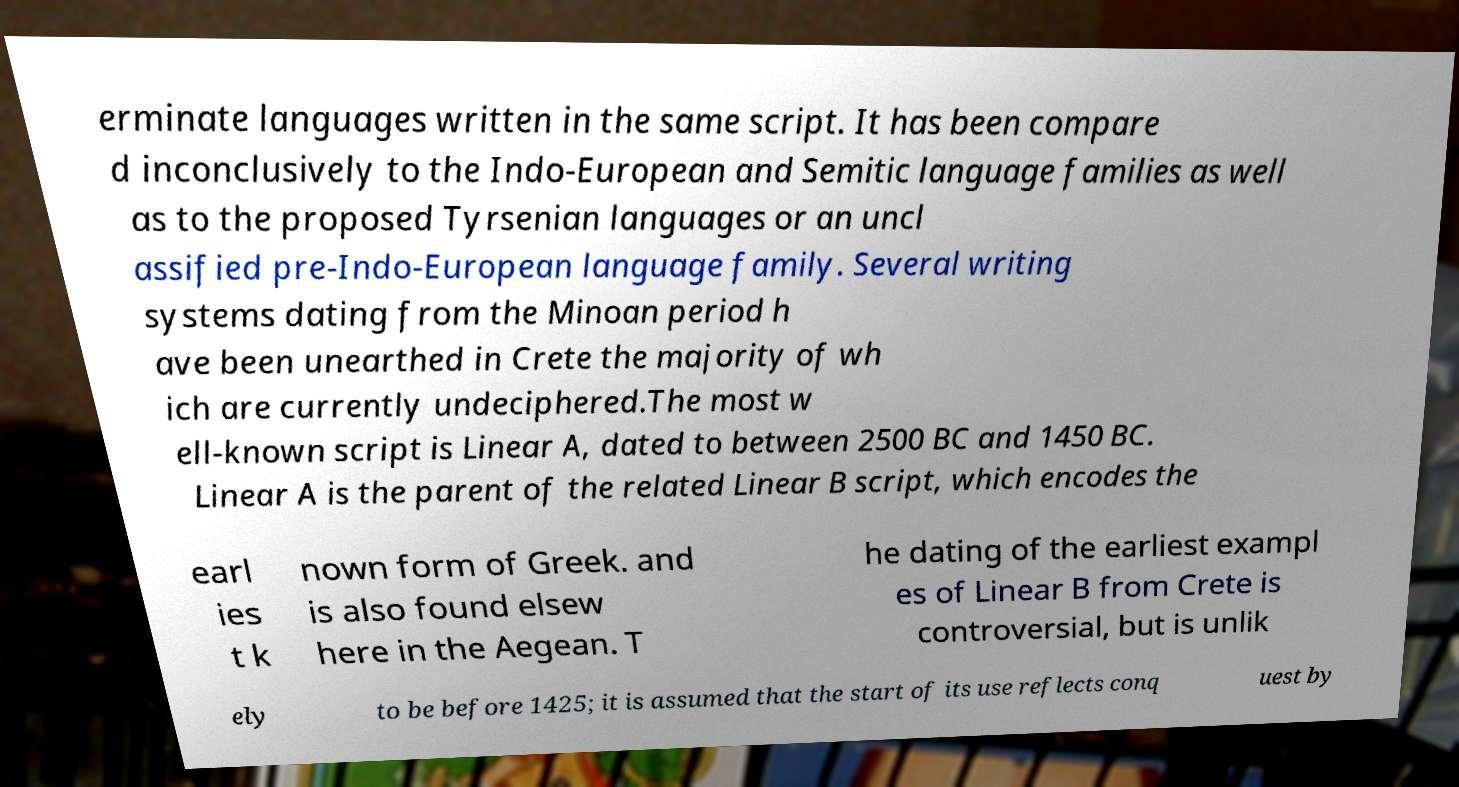Can you read and provide the text displayed in the image?This photo seems to have some interesting text. Can you extract and type it out for me? erminate languages written in the same script. It has been compare d inconclusively to the Indo-European and Semitic language families as well as to the proposed Tyrsenian languages or an uncl assified pre-Indo-European language family. Several writing systems dating from the Minoan period h ave been unearthed in Crete the majority of wh ich are currently undeciphered.The most w ell-known script is Linear A, dated to between 2500 BC and 1450 BC. Linear A is the parent of the related Linear B script, which encodes the earl ies t k nown form of Greek. and is also found elsew here in the Aegean. T he dating of the earliest exampl es of Linear B from Crete is controversial, but is unlik ely to be before 1425; it is assumed that the start of its use reflects conq uest by 